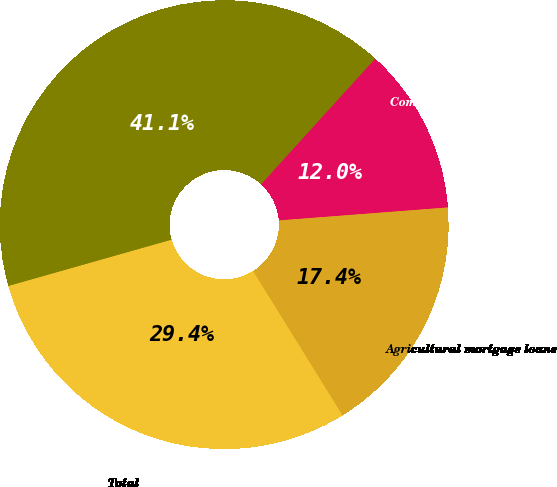Convert chart. <chart><loc_0><loc_0><loc_500><loc_500><pie_chart><fcel>Commercial mortgage loans<fcel>Agricultural mortgage loans<fcel>Total<fcel>Total mortgage loans at<nl><fcel>12.04%<fcel>17.39%<fcel>29.43%<fcel>41.14%<nl></chart> 